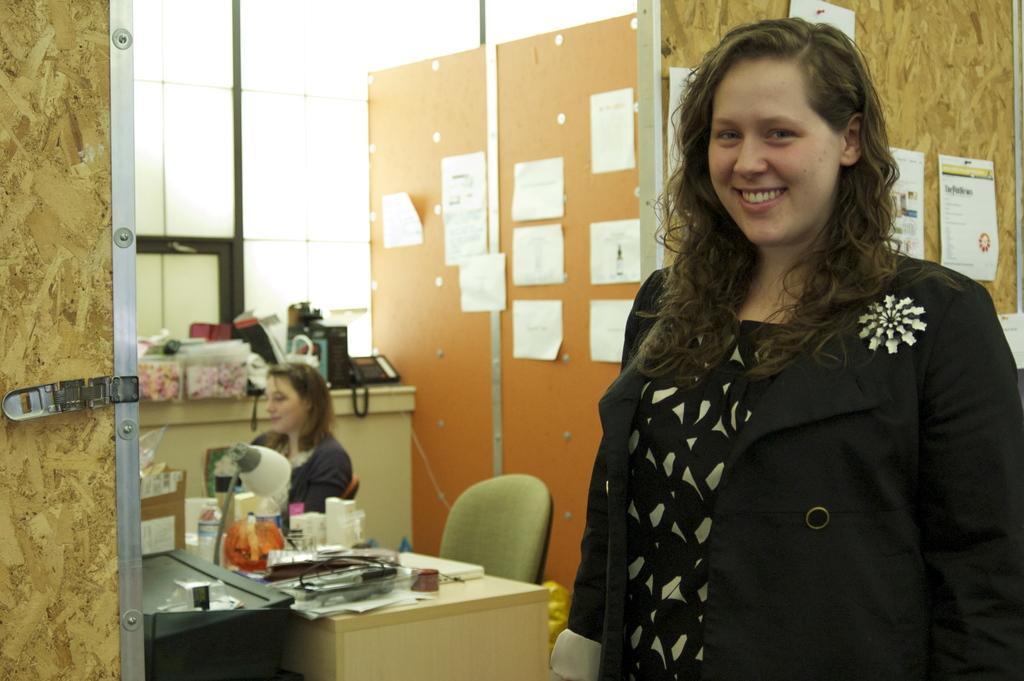In one or two sentences, can you explain what this image depicts? Here we can see a woman is standing and she is smiling, and at side a person is sitting, and in front her is the table and lamp and some objects on it, and here is the wall and papers on it. 